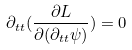<formula> <loc_0><loc_0><loc_500><loc_500>\partial _ { t t } ( \frac { \partial L } { \partial ( \partial _ { t t } \psi ) } ) = 0</formula> 